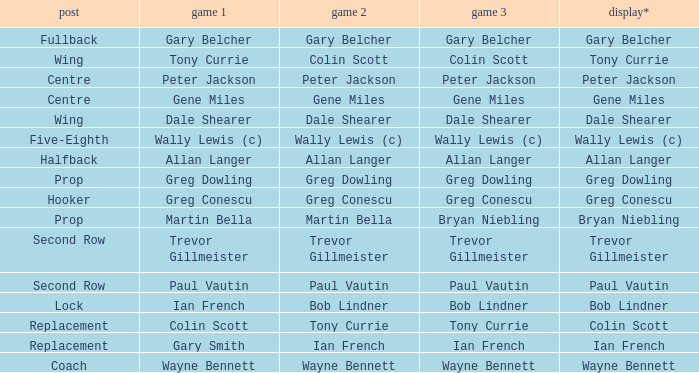Wjat game 3 has ian french as a game of 2? Ian French. 